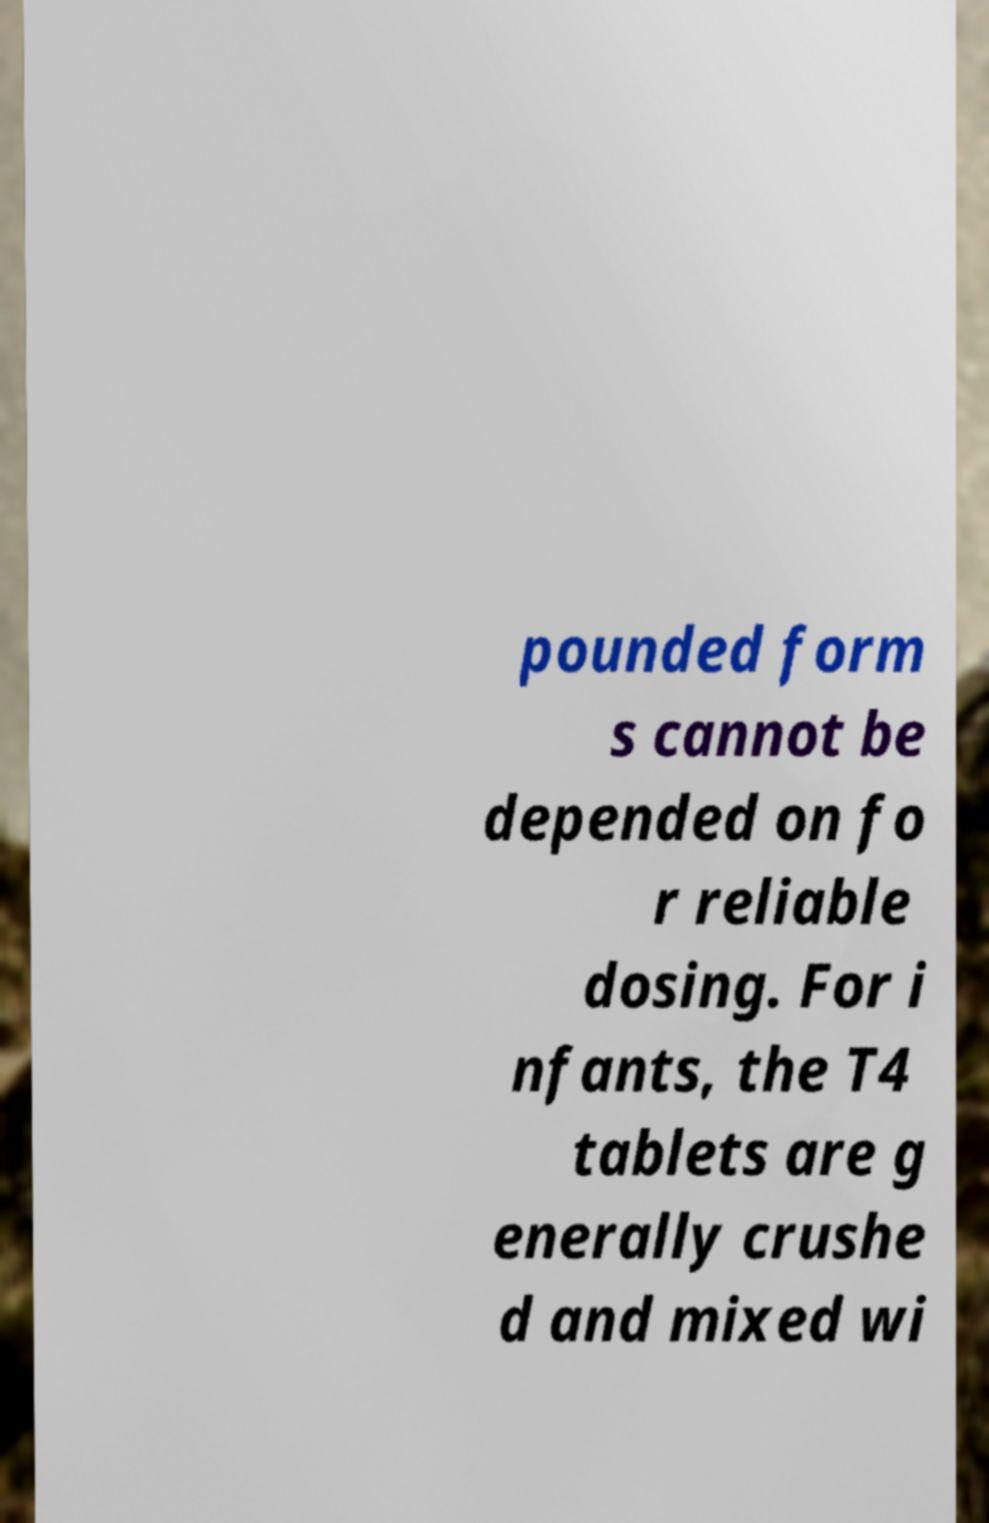Please identify and transcribe the text found in this image. pounded form s cannot be depended on fo r reliable dosing. For i nfants, the T4 tablets are g enerally crushe d and mixed wi 